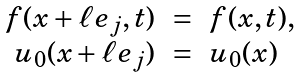<formula> <loc_0><loc_0><loc_500><loc_500>\begin{array} { r c l } f ( x + \ell e _ { j } , t ) & = & f ( x , t ) , \\ u _ { 0 } ( x + \ell e _ { j } ) & = & u _ { 0 } ( x ) \end{array}</formula> 